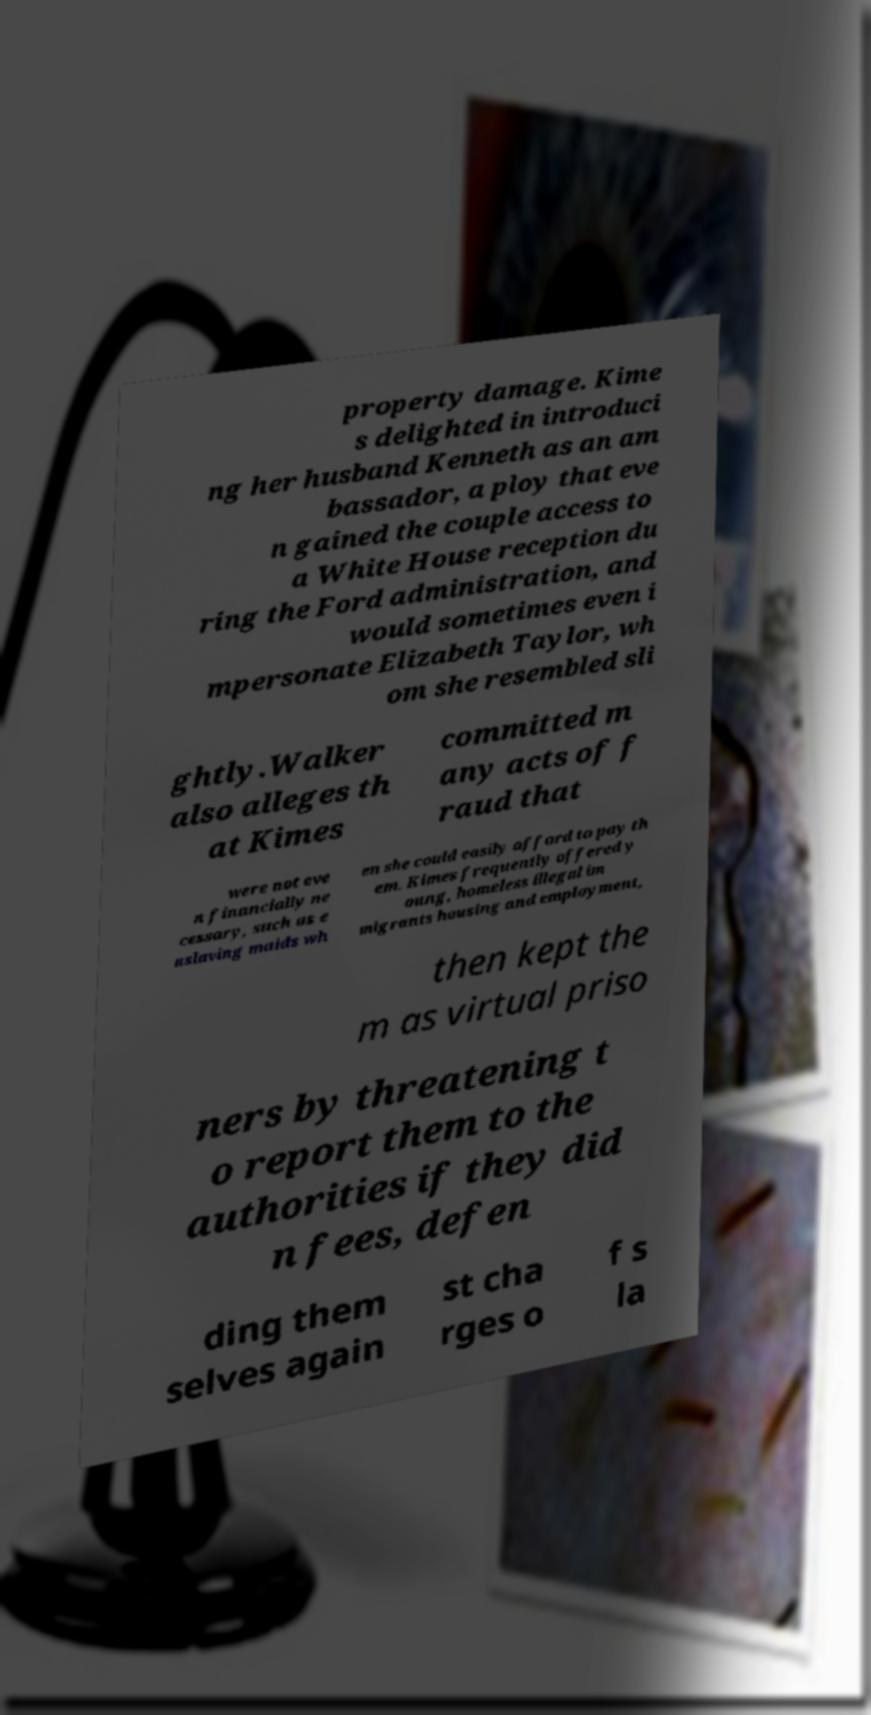Could you assist in decoding the text presented in this image and type it out clearly? property damage. Kime s delighted in introduci ng her husband Kenneth as an am bassador, a ploy that eve n gained the couple access to a White House reception du ring the Ford administration, and would sometimes even i mpersonate Elizabeth Taylor, wh om she resembled sli ghtly.Walker also alleges th at Kimes committed m any acts of f raud that were not eve n financially ne cessary, such as e nslaving maids wh en she could easily afford to pay th em. Kimes frequently offered y oung, homeless illegal im migrants housing and employment, then kept the m as virtual priso ners by threatening t o report them to the authorities if they did n fees, defen ding them selves again st cha rges o f s la 